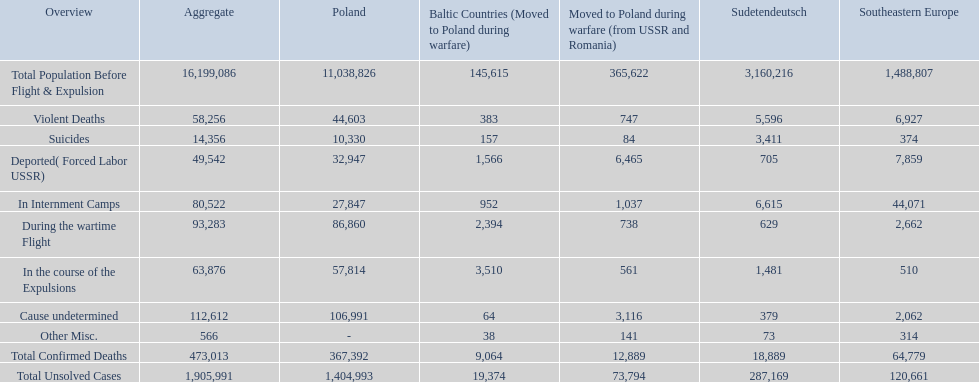What were the total number of confirmed deaths? 473,013. Of these, how many were violent? 58,256. 